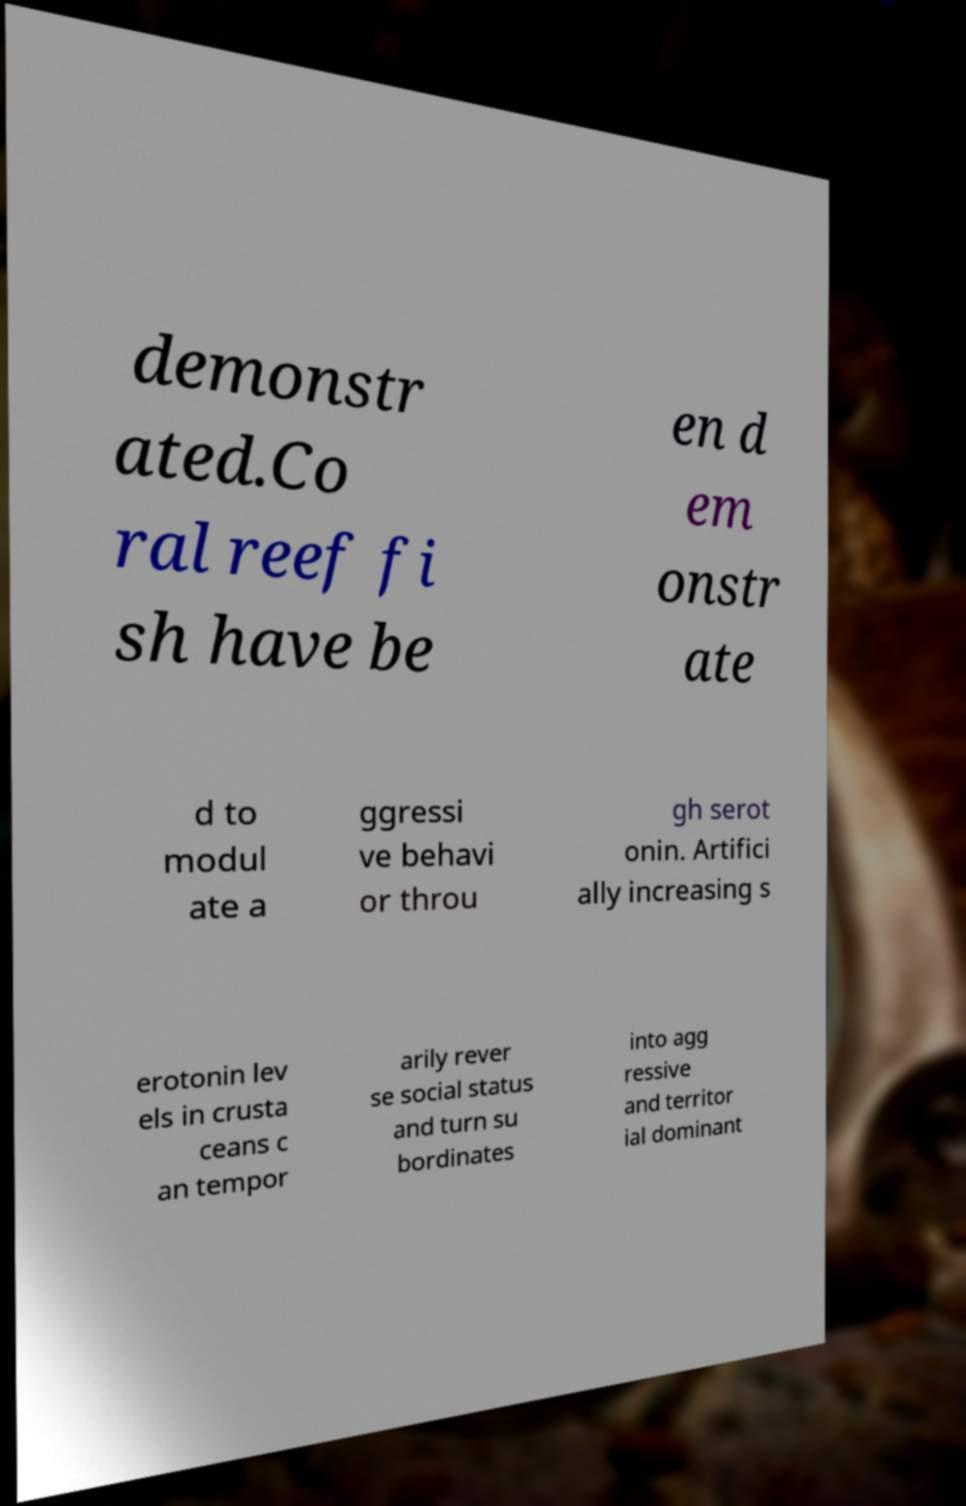Could you extract and type out the text from this image? demonstr ated.Co ral reef fi sh have be en d em onstr ate d to modul ate a ggressi ve behavi or throu gh serot onin. Artifici ally increasing s erotonin lev els in crusta ceans c an tempor arily rever se social status and turn su bordinates into agg ressive and territor ial dominant 